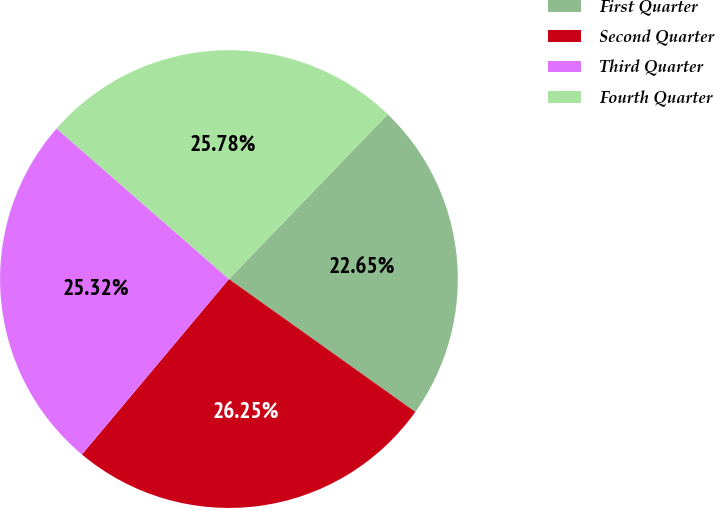<chart> <loc_0><loc_0><loc_500><loc_500><pie_chart><fcel>First Quarter<fcel>Second Quarter<fcel>Third Quarter<fcel>Fourth Quarter<nl><fcel>22.65%<fcel>26.25%<fcel>25.32%<fcel>25.78%<nl></chart> 